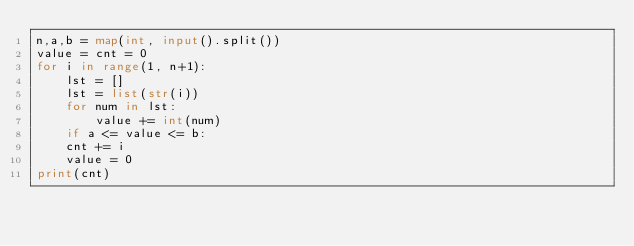<code> <loc_0><loc_0><loc_500><loc_500><_Python_>n,a,b = map(int, input().split())
value = cnt = 0
for i in range(1, n+1):
    lst = []
    lst = list(str(i))
    for num in lst:
        value += int(num)
    if a <= value <= b:
    cnt += i
    value = 0
print(cnt)</code> 